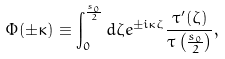Convert formula to latex. <formula><loc_0><loc_0><loc_500><loc_500>\Phi ( \pm \kappa ) \equiv \int _ { 0 } ^ { \frac { s _ { 0 } } { 2 } } d \zeta e ^ { \pm i \kappa \zeta } \frac { \tau ^ { \prime } ( \zeta ) } { \tau \left ( \frac { s _ { 0 } } { 2 } \right ) } ,</formula> 